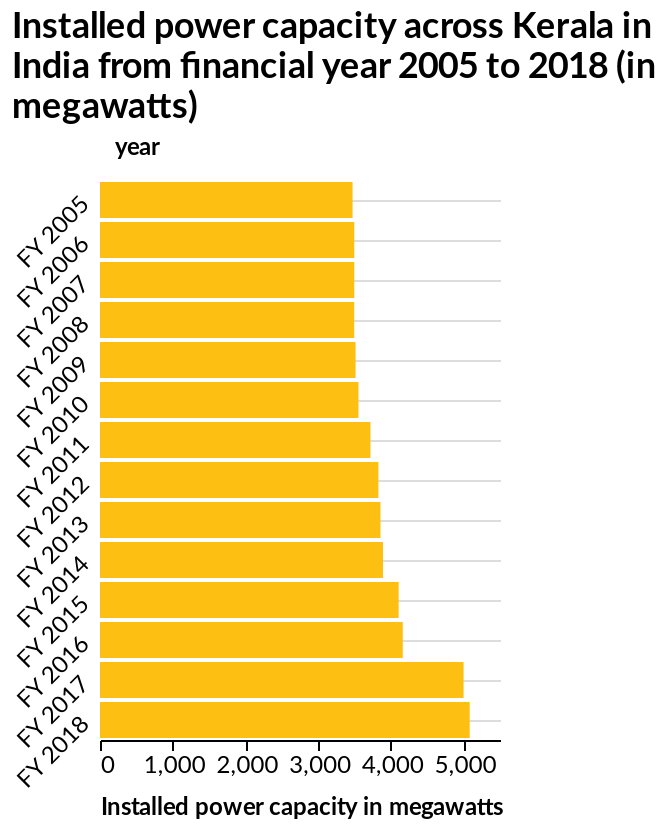<image>
What was the trend in megawatts from FY 2014 to FY 2015? The trend in megawatts from FY 2014 to FY 2015 is not mentioned in the description. What is the measurement unit of installed power capacity in Kerala from FY 2005 to FY 2018? The measurement unit of installed power capacity in Kerala from FY 2005 to FY 2018 is in megawatts. Offer a thorough analysis of the image. The power capacity showed very slow growth between 2005 to 2016. There was no growth between 2006 and 2008 as capacity stayed the same. From 2009 to 2016 there was positive growth in capacity. Growth increased substantially between 2016 and 2017 before it slowed again in 2018. What does the y-axis represent in the bar plot? The y-axis in the bar plot represents the years, measured from FY 2005 to FY 2018. What is the general trend of installed power capacity in Kerala from FY 2005 to FY 2018? The general trend of installed power capacity in Kerala from FY 2005 to FY 2018 can be observed by analyzing the bar plot. Did the power capacity show extremely rapid growth between 2005 to 2016? No.The power capacity showed very slow growth between 2005 to 2016. There was no growth between 2006 and 2008 as capacity stayed the same. From 2009 to 2016 there was positive growth in capacity. Growth increased substantially between 2016 and 2017 before it slowed again in 2018. Does the x-axis in the bar plot represent the years, measured from FY 2005 to FY 2018? No.The y-axis in the bar plot represents the years, measured from FY 2005 to FY 2018. 